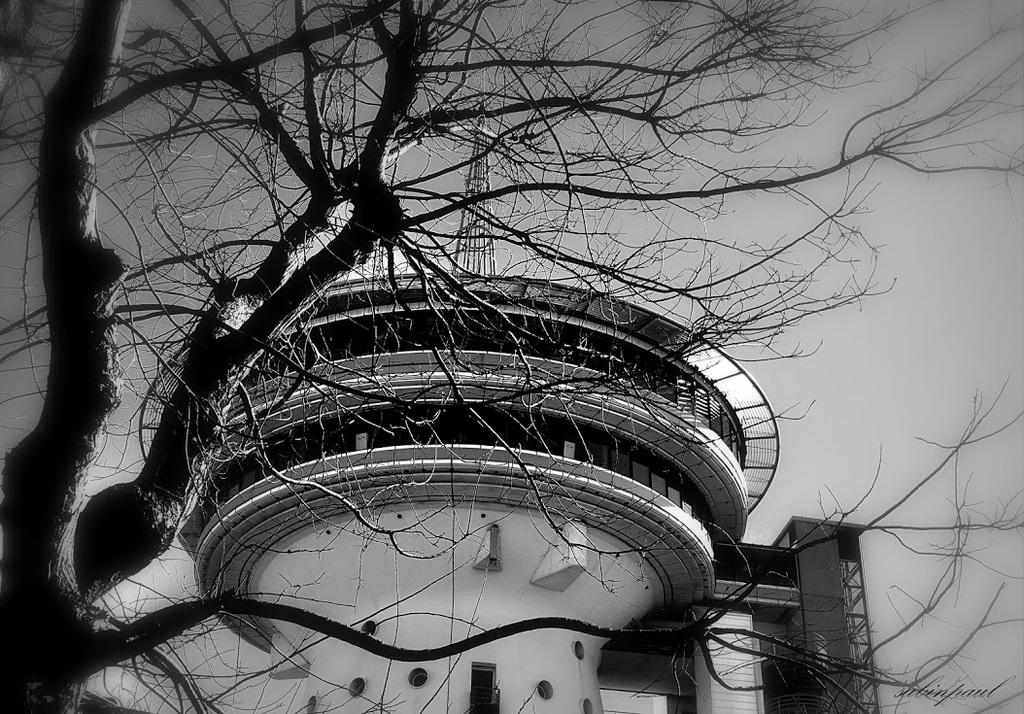What is the main structure visible in the image? There is a building in the image. What is located in front of the building? There is a tree in front of the building. What can be seen in the background of the image? The sky is visible in the background of the image. What type of muscle is being exercised by the tree in the image? There is no muscle being exercised by the tree in the image, as trees do not have muscles. 